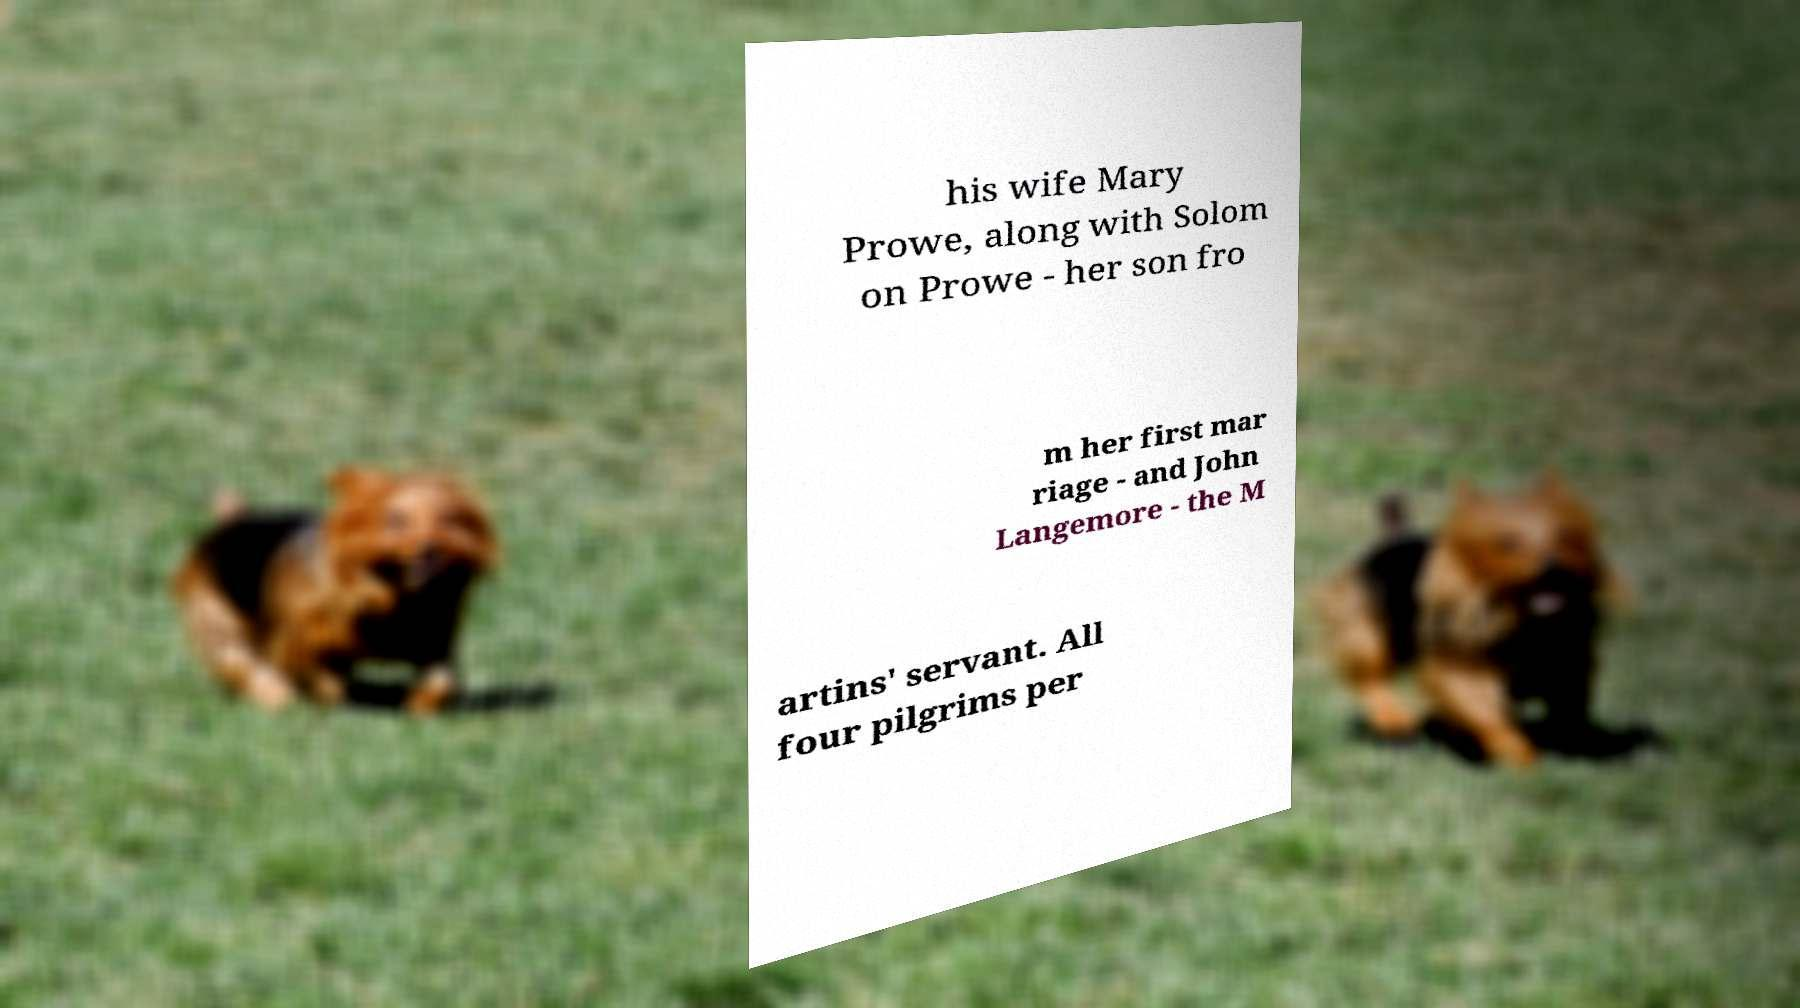Could you assist in decoding the text presented in this image and type it out clearly? his wife Mary Prowe, along with Solom on Prowe - her son fro m her first mar riage - and John Langemore - the M artins' servant. All four pilgrims per 